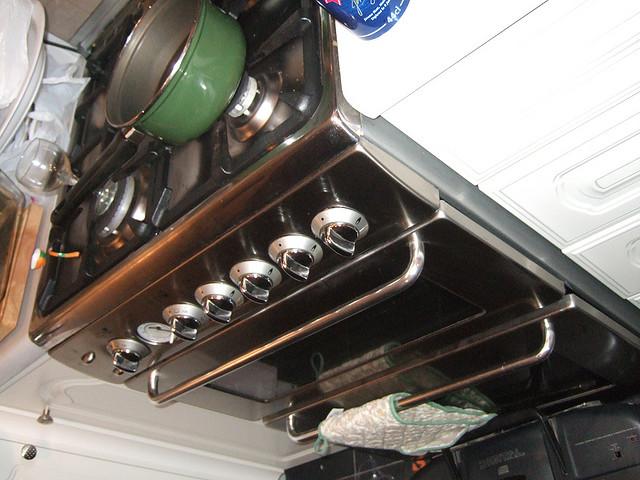What number of knobs are on this oven door?
Be succinct. 6. Are there dishes on the stove?
Short answer required. Yes. What room is this?
Concise answer only. Kitchen. 